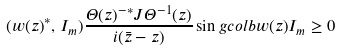Convert formula to latex. <formula><loc_0><loc_0><loc_500><loc_500>( w ( z ) ^ { * } , \, I _ { m } ) \frac { \Theta ( z ) ^ { - * } J \Theta ^ { - 1 } ( z ) } { i ( \bar { z } - z ) } \sin g c o l b { w ( z ) } { I _ { m } } \geq 0</formula> 